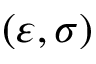<formula> <loc_0><loc_0><loc_500><loc_500>( \varepsilon , \sigma )</formula> 